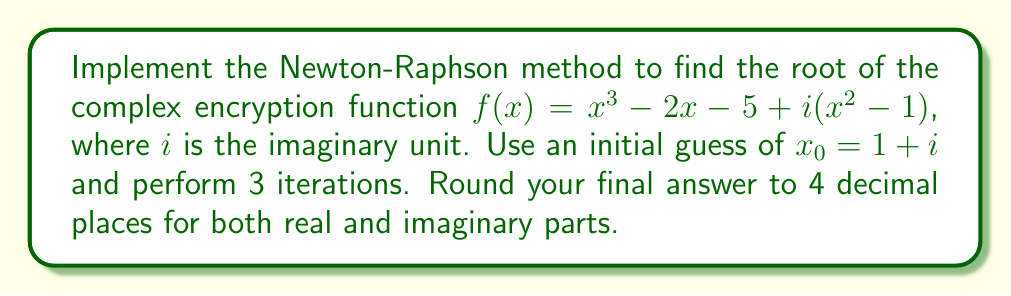Teach me how to tackle this problem. To implement the Newton-Raphson method for a complex function, we use the formula:

$$x_{n+1} = x_n - \frac{f(x_n)}{f'(x_n)}$$

where $f'(x)$ is the derivative of $f(x)$.

Step 1: Calculate $f'(x)$
$f'(x) = 3x^2 - 2 + i(2x)$

Step 2: Implement the Newton-Raphson method
Starting with $x_0 = 1 + i$, we'll perform 3 iterations:

Iteration 1:
$f(x_0) = (1+i)^3 - 2(1+i) - 5 + i((1+i)^2 - 1) = -3 + 2i$
$f'(x_0) = 3(1+i)^2 - 2 + i(2(1+i)) = 4 + 6i$

$$x_1 = (1+i) - \frac{-3 + 2i}{4 + 6i} = 1.4 + 0.8i$$

Iteration 2:
$f(x_1) = (1.4+0.8i)^3 - 2(1.4+0.8i) - 5 + i((1.4+0.8i)^2 - 1) = -0.664 + 0.688i$
$f'(x_1) = 3(1.4+0.8i)^2 - 2 + i(2(1.4+0.8i)) = 5.12 + 6.72i$

$$x_2 = (1.4+0.8i) - \frac{-0.664 + 0.688i}{5.12 + 6.72i} = 1.5306 + 0.6474i$$

Iteration 3:
$f(x_2) = (1.5306+0.6474i)^3 - 2(1.5306+0.6474i) - 5 + i((1.5306+0.6474i)^2 - 1) = -0.0187 + 0.0305i$
$f'(x_2) = 3(1.5306+0.6474i)^2 - 2 + i(2(1.5306+0.6474i)) = 5.5909 + 6.0175i$

$$x_3 = (1.5306+0.6474i) - \frac{-0.0187 + 0.0305i}{5.5909 + 6.0175i} = 1.5321 + 0.6425i$$

Step 3: Round the final result to 4 decimal places
$x_3 \approx 1.5321 + 0.6425i$
Answer: $1.5321 + 0.6425i$ 